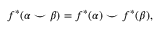<formula> <loc_0><loc_0><loc_500><loc_500>f ^ { * } ( \alpha \smile \beta ) = f ^ { * } ( \alpha ) \smile f ^ { * } ( \beta ) ,</formula> 